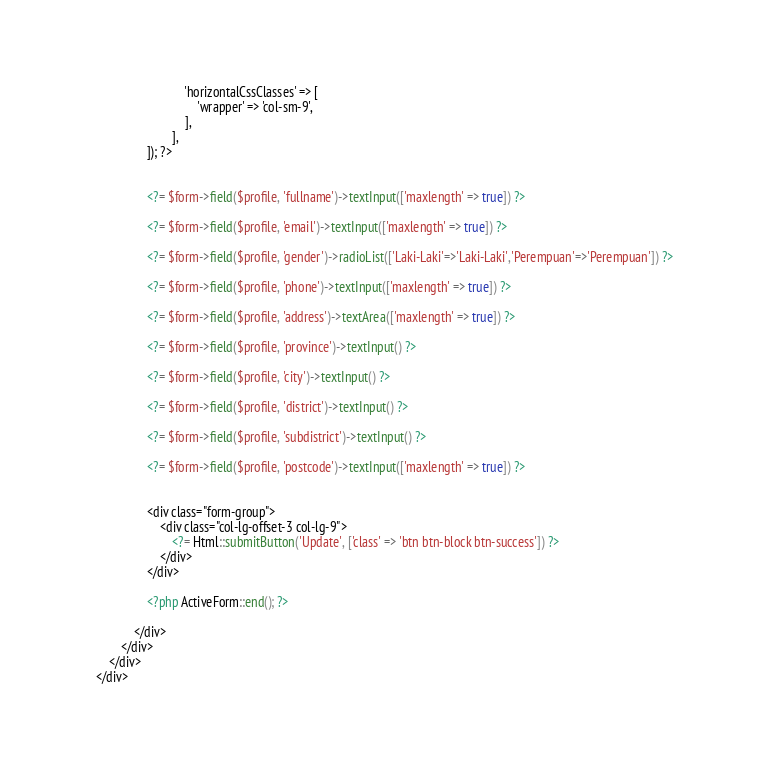Convert code to text. <code><loc_0><loc_0><loc_500><loc_500><_PHP_>                                'horizontalCssClasses' => [
                                    'wrapper' => 'col-sm-9',
                                ],
                            ],
                    ]); ?>


                    <?= $form->field($profile, 'fullname')->textInput(['maxlength' => true]) ?>

                    <?= $form->field($profile, 'email')->textInput(['maxlength' => true]) ?>

                    <?= $form->field($profile, 'gender')->radioList(['Laki-Laki'=>'Laki-Laki','Perempuan'=>'Perempuan']) ?>

                    <?= $form->field($profile, 'phone')->textInput(['maxlength' => true]) ?>

                    <?= $form->field($profile, 'address')->textArea(['maxlength' => true]) ?>

                    <?= $form->field($profile, 'province')->textInput() ?>

                    <?= $form->field($profile, 'city')->textInput() ?>

                    <?= $form->field($profile, 'district')->textInput() ?>

                    <?= $form->field($profile, 'subdistrict')->textInput() ?>

                    <?= $form->field($profile, 'postcode')->textInput(['maxlength' => true]) ?>


                    <div class="form-group">
                        <div class="col-lg-offset-3 col-lg-9">
                            <?= Html::submitButton('Update', ['class' => 'btn btn-block btn-success']) ?>
                        </div>
                    </div>

                    <?php ActiveForm::end(); ?>

                </div>
            </div>
        </div>
    </div>

</code> 